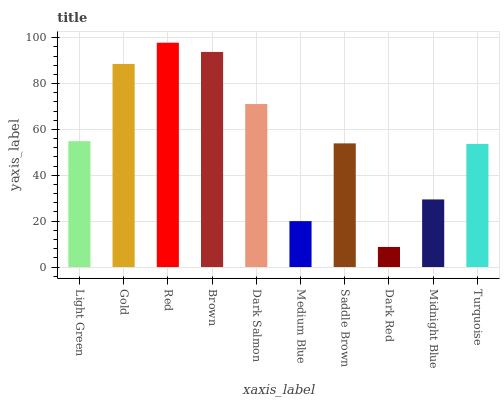Is Dark Red the minimum?
Answer yes or no. Yes. Is Red the maximum?
Answer yes or no. Yes. Is Gold the minimum?
Answer yes or no. No. Is Gold the maximum?
Answer yes or no. No. Is Gold greater than Light Green?
Answer yes or no. Yes. Is Light Green less than Gold?
Answer yes or no. Yes. Is Light Green greater than Gold?
Answer yes or no. No. Is Gold less than Light Green?
Answer yes or no. No. Is Light Green the high median?
Answer yes or no. Yes. Is Saddle Brown the low median?
Answer yes or no. Yes. Is Brown the high median?
Answer yes or no. No. Is Turquoise the low median?
Answer yes or no. No. 